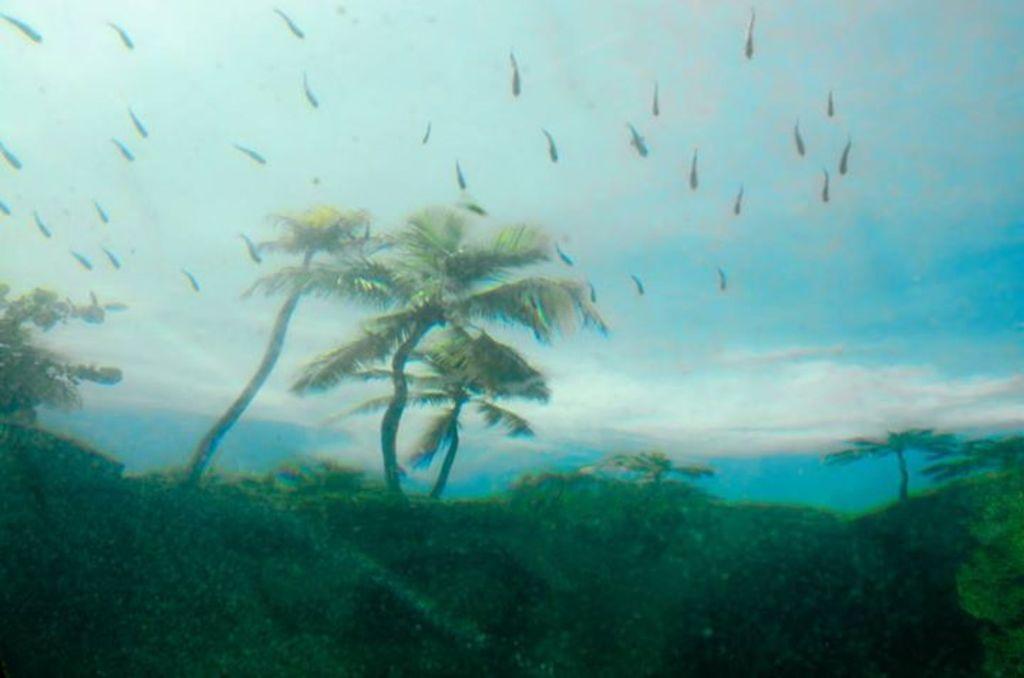Could you give a brief overview of what you see in this image? In the image we can see there is a poster in which there are lot of trees and there are hills. There are birds flying in the sky. 